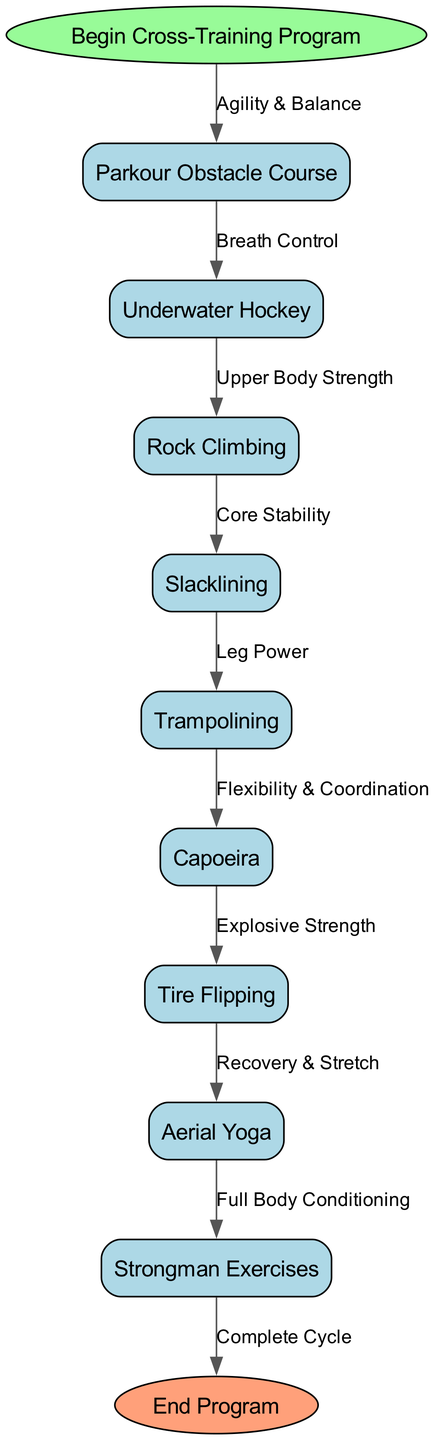What is the start node of the flowchart? The start node is labeled "Begin Cross-Training Program." It is the first element in the diagram where the training process begins.
Answer: Begin Cross-Training Program How many nodes are present in the diagram? The diagram contains a total of 10 nodes, including the start and end nodes, and the unconventional exercises listed in between.
Answer: 10 What is the activity after "Slacklining"? According to the flowchart, the activity following "Slacklining" is "Trampolining," connected through the arrow representing the relationship.
Answer: Trampolining Which exercise focuses on "Flexibility & Coordination"? The "Capoeira" exercise is specifically linked with the focus on "Flexibility & Coordination," as denoted in the edge label from the preceding activity.
Answer: Capoeira How many edges are in the diagram? The diagram features a total of 9 edges representing connections between nodes, showing the flow of the cross-training program from start to finish.
Answer: 9 What is the last activity prior to ending the program? The final activity leading to the end of the program is "Strongman Exercises," which completes the cycle before transitioning to the end node.
Answer: Strongman Exercises What exercise comes before "Tire Flipping"? "Capoeira" is the exercise that comes directly before "Tire Flipping," as indicated by the flow of the diagram.
Answer: Capoeira What type of strength is emphasized in "Underwater Hockey"? The focus of "Underwater Hockey" is on "Breath Control," creating a connection to the next exercise in the sequence.
Answer: Breath Control Which two activities promote "Upper Body Strength"? "Underwater Hockey" and "Rock Climbing" are the two activities in the flowchart that emphasize "Upper Body Strength," with the latter following the former in sequence.
Answer: Underwater Hockey and Rock Climbing 